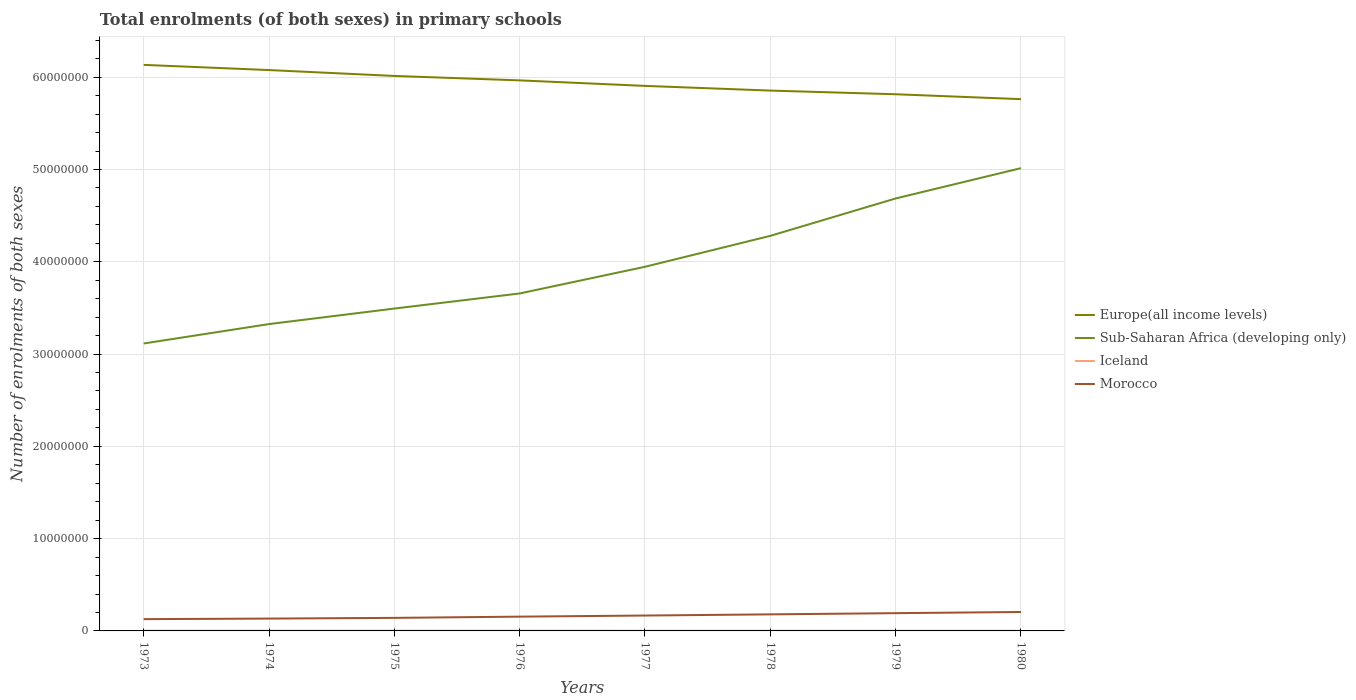How many different coloured lines are there?
Your response must be concise. 4. Across all years, what is the maximum number of enrolments in primary schools in Iceland?
Provide a short and direct response. 2.46e+04. What is the total number of enrolments in primary schools in Europe(all income levels) in the graph?
Provide a short and direct response. 1.44e+06. What is the difference between the highest and the second highest number of enrolments in primary schools in Europe(all income levels)?
Your answer should be compact. 3.71e+06. Is the number of enrolments in primary schools in Europe(all income levels) strictly greater than the number of enrolments in primary schools in Sub-Saharan Africa (developing only) over the years?
Ensure brevity in your answer.  No. How many lines are there?
Give a very brief answer. 4. Does the graph contain any zero values?
Offer a very short reply. No. Does the graph contain grids?
Keep it short and to the point. Yes. Where does the legend appear in the graph?
Provide a short and direct response. Center right. How many legend labels are there?
Your response must be concise. 4. How are the legend labels stacked?
Offer a very short reply. Vertical. What is the title of the graph?
Offer a very short reply. Total enrolments (of both sexes) in primary schools. What is the label or title of the X-axis?
Ensure brevity in your answer.  Years. What is the label or title of the Y-axis?
Give a very brief answer. Number of enrolments of both sexes. What is the Number of enrolments of both sexes in Europe(all income levels) in 1973?
Your answer should be compact. 6.13e+07. What is the Number of enrolments of both sexes of Sub-Saharan Africa (developing only) in 1973?
Your answer should be compact. 3.11e+07. What is the Number of enrolments of both sexes in Iceland in 1973?
Your answer should be compact. 2.72e+04. What is the Number of enrolments of both sexes in Morocco in 1973?
Offer a terse response. 1.28e+06. What is the Number of enrolments of both sexes of Europe(all income levels) in 1974?
Provide a short and direct response. 6.08e+07. What is the Number of enrolments of both sexes of Sub-Saharan Africa (developing only) in 1974?
Provide a succinct answer. 3.32e+07. What is the Number of enrolments of both sexes in Iceland in 1974?
Ensure brevity in your answer.  2.70e+04. What is the Number of enrolments of both sexes in Morocco in 1974?
Offer a terse response. 1.34e+06. What is the Number of enrolments of both sexes in Europe(all income levels) in 1975?
Offer a terse response. 6.01e+07. What is the Number of enrolments of both sexes in Sub-Saharan Africa (developing only) in 1975?
Provide a short and direct response. 3.49e+07. What is the Number of enrolments of both sexes in Iceland in 1975?
Provide a succinct answer. 2.69e+04. What is the Number of enrolments of both sexes of Morocco in 1975?
Provide a succinct answer. 1.41e+06. What is the Number of enrolments of both sexes in Europe(all income levels) in 1976?
Provide a short and direct response. 5.97e+07. What is the Number of enrolments of both sexes in Sub-Saharan Africa (developing only) in 1976?
Keep it short and to the point. 3.66e+07. What is the Number of enrolments of both sexes of Iceland in 1976?
Your response must be concise. 2.64e+04. What is the Number of enrolments of both sexes in Morocco in 1976?
Ensure brevity in your answer.  1.55e+06. What is the Number of enrolments of both sexes in Europe(all income levels) in 1977?
Your response must be concise. 5.91e+07. What is the Number of enrolments of both sexes in Sub-Saharan Africa (developing only) in 1977?
Make the answer very short. 3.95e+07. What is the Number of enrolments of both sexes of Iceland in 1977?
Provide a short and direct response. 2.59e+04. What is the Number of enrolments of both sexes in Morocco in 1977?
Your answer should be compact. 1.67e+06. What is the Number of enrolments of both sexes in Europe(all income levels) in 1978?
Provide a succinct answer. 5.86e+07. What is the Number of enrolments of both sexes of Sub-Saharan Africa (developing only) in 1978?
Give a very brief answer. 4.28e+07. What is the Number of enrolments of both sexes in Iceland in 1978?
Make the answer very short. 2.51e+04. What is the Number of enrolments of both sexes of Morocco in 1978?
Keep it short and to the point. 1.79e+06. What is the Number of enrolments of both sexes of Europe(all income levels) in 1979?
Give a very brief answer. 5.82e+07. What is the Number of enrolments of both sexes of Sub-Saharan Africa (developing only) in 1979?
Provide a short and direct response. 4.69e+07. What is the Number of enrolments of both sexes in Iceland in 1979?
Your response must be concise. 2.47e+04. What is the Number of enrolments of both sexes of Morocco in 1979?
Your answer should be very brief. 1.93e+06. What is the Number of enrolments of both sexes in Europe(all income levels) in 1980?
Ensure brevity in your answer.  5.76e+07. What is the Number of enrolments of both sexes in Sub-Saharan Africa (developing only) in 1980?
Offer a very short reply. 5.01e+07. What is the Number of enrolments of both sexes of Iceland in 1980?
Offer a very short reply. 2.46e+04. What is the Number of enrolments of both sexes in Morocco in 1980?
Provide a succinct answer. 2.05e+06. Across all years, what is the maximum Number of enrolments of both sexes of Europe(all income levels)?
Make the answer very short. 6.13e+07. Across all years, what is the maximum Number of enrolments of both sexes in Sub-Saharan Africa (developing only)?
Offer a terse response. 5.01e+07. Across all years, what is the maximum Number of enrolments of both sexes in Iceland?
Provide a succinct answer. 2.72e+04. Across all years, what is the maximum Number of enrolments of both sexes of Morocco?
Your response must be concise. 2.05e+06. Across all years, what is the minimum Number of enrolments of both sexes of Europe(all income levels)?
Offer a terse response. 5.76e+07. Across all years, what is the minimum Number of enrolments of both sexes of Sub-Saharan Africa (developing only)?
Your answer should be very brief. 3.11e+07. Across all years, what is the minimum Number of enrolments of both sexes of Iceland?
Your answer should be compact. 2.46e+04. Across all years, what is the minimum Number of enrolments of both sexes of Morocco?
Give a very brief answer. 1.28e+06. What is the total Number of enrolments of both sexes of Europe(all income levels) in the graph?
Make the answer very short. 4.75e+08. What is the total Number of enrolments of both sexes of Sub-Saharan Africa (developing only) in the graph?
Provide a short and direct response. 3.15e+08. What is the total Number of enrolments of both sexes of Iceland in the graph?
Ensure brevity in your answer.  2.08e+05. What is the total Number of enrolments of both sexes of Morocco in the graph?
Provide a short and direct response. 1.30e+07. What is the difference between the Number of enrolments of both sexes in Europe(all income levels) in 1973 and that in 1974?
Provide a succinct answer. 5.63e+05. What is the difference between the Number of enrolments of both sexes of Sub-Saharan Africa (developing only) in 1973 and that in 1974?
Your response must be concise. -2.10e+06. What is the difference between the Number of enrolments of both sexes in Iceland in 1973 and that in 1974?
Ensure brevity in your answer.  171. What is the difference between the Number of enrolments of both sexes of Morocco in 1973 and that in 1974?
Your answer should be very brief. -6.21e+04. What is the difference between the Number of enrolments of both sexes in Europe(all income levels) in 1973 and that in 1975?
Provide a succinct answer. 1.20e+06. What is the difference between the Number of enrolments of both sexes of Sub-Saharan Africa (developing only) in 1973 and that in 1975?
Provide a succinct answer. -3.79e+06. What is the difference between the Number of enrolments of both sexes of Iceland in 1973 and that in 1975?
Provide a succinct answer. 295. What is the difference between the Number of enrolments of both sexes in Morocco in 1973 and that in 1975?
Your answer should be very brief. -1.38e+05. What is the difference between the Number of enrolments of both sexes of Europe(all income levels) in 1973 and that in 1976?
Offer a terse response. 1.68e+06. What is the difference between the Number of enrolments of both sexes of Sub-Saharan Africa (developing only) in 1973 and that in 1976?
Your answer should be compact. -5.42e+06. What is the difference between the Number of enrolments of both sexes in Iceland in 1973 and that in 1976?
Your answer should be compact. 799. What is the difference between the Number of enrolments of both sexes of Morocco in 1973 and that in 1976?
Your response must be concise. -2.72e+05. What is the difference between the Number of enrolments of both sexes of Europe(all income levels) in 1973 and that in 1977?
Your response must be concise. 2.28e+06. What is the difference between the Number of enrolments of both sexes in Sub-Saharan Africa (developing only) in 1973 and that in 1977?
Your answer should be very brief. -8.31e+06. What is the difference between the Number of enrolments of both sexes of Iceland in 1973 and that in 1977?
Give a very brief answer. 1293. What is the difference between the Number of enrolments of both sexes of Morocco in 1973 and that in 1977?
Ensure brevity in your answer.  -3.92e+05. What is the difference between the Number of enrolments of both sexes in Europe(all income levels) in 1973 and that in 1978?
Ensure brevity in your answer.  2.79e+06. What is the difference between the Number of enrolments of both sexes in Sub-Saharan Africa (developing only) in 1973 and that in 1978?
Ensure brevity in your answer.  -1.17e+07. What is the difference between the Number of enrolments of both sexes in Iceland in 1973 and that in 1978?
Keep it short and to the point. 2079. What is the difference between the Number of enrolments of both sexes in Morocco in 1973 and that in 1978?
Provide a succinct answer. -5.18e+05. What is the difference between the Number of enrolments of both sexes in Europe(all income levels) in 1973 and that in 1979?
Offer a very short reply. 3.18e+06. What is the difference between the Number of enrolments of both sexes of Sub-Saharan Africa (developing only) in 1973 and that in 1979?
Your response must be concise. -1.57e+07. What is the difference between the Number of enrolments of both sexes in Iceland in 1973 and that in 1979?
Offer a terse response. 2530. What is the difference between the Number of enrolments of both sexes of Morocco in 1973 and that in 1979?
Offer a very short reply. -6.49e+05. What is the difference between the Number of enrolments of both sexes of Europe(all income levels) in 1973 and that in 1980?
Ensure brevity in your answer.  3.71e+06. What is the difference between the Number of enrolments of both sexes in Sub-Saharan Africa (developing only) in 1973 and that in 1980?
Ensure brevity in your answer.  -1.90e+07. What is the difference between the Number of enrolments of both sexes in Iceland in 1973 and that in 1980?
Give a very brief answer. 2618. What is the difference between the Number of enrolments of both sexes in Morocco in 1973 and that in 1980?
Ensure brevity in your answer.  -7.76e+05. What is the difference between the Number of enrolments of both sexes in Europe(all income levels) in 1974 and that in 1975?
Your answer should be compact. 6.37e+05. What is the difference between the Number of enrolments of both sexes of Sub-Saharan Africa (developing only) in 1974 and that in 1975?
Give a very brief answer. -1.68e+06. What is the difference between the Number of enrolments of both sexes of Iceland in 1974 and that in 1975?
Your response must be concise. 124. What is the difference between the Number of enrolments of both sexes of Morocco in 1974 and that in 1975?
Your response must be concise. -7.61e+04. What is the difference between the Number of enrolments of both sexes in Europe(all income levels) in 1974 and that in 1976?
Make the answer very short. 1.12e+06. What is the difference between the Number of enrolments of both sexes of Sub-Saharan Africa (developing only) in 1974 and that in 1976?
Your answer should be compact. -3.32e+06. What is the difference between the Number of enrolments of both sexes of Iceland in 1974 and that in 1976?
Your answer should be very brief. 628. What is the difference between the Number of enrolments of both sexes of Morocco in 1974 and that in 1976?
Make the answer very short. -2.10e+05. What is the difference between the Number of enrolments of both sexes in Europe(all income levels) in 1974 and that in 1977?
Make the answer very short. 1.72e+06. What is the difference between the Number of enrolments of both sexes in Sub-Saharan Africa (developing only) in 1974 and that in 1977?
Your answer should be very brief. -6.21e+06. What is the difference between the Number of enrolments of both sexes of Iceland in 1974 and that in 1977?
Provide a succinct answer. 1122. What is the difference between the Number of enrolments of both sexes in Morocco in 1974 and that in 1977?
Provide a succinct answer. -3.30e+05. What is the difference between the Number of enrolments of both sexes of Europe(all income levels) in 1974 and that in 1978?
Offer a terse response. 2.22e+06. What is the difference between the Number of enrolments of both sexes in Sub-Saharan Africa (developing only) in 1974 and that in 1978?
Provide a short and direct response. -9.56e+06. What is the difference between the Number of enrolments of both sexes of Iceland in 1974 and that in 1978?
Provide a succinct answer. 1908. What is the difference between the Number of enrolments of both sexes of Morocco in 1974 and that in 1978?
Offer a terse response. -4.56e+05. What is the difference between the Number of enrolments of both sexes in Europe(all income levels) in 1974 and that in 1979?
Make the answer very short. 2.62e+06. What is the difference between the Number of enrolments of both sexes of Sub-Saharan Africa (developing only) in 1974 and that in 1979?
Offer a terse response. -1.36e+07. What is the difference between the Number of enrolments of both sexes in Iceland in 1974 and that in 1979?
Your answer should be very brief. 2359. What is the difference between the Number of enrolments of both sexes of Morocco in 1974 and that in 1979?
Your answer should be compact. -5.87e+05. What is the difference between the Number of enrolments of both sexes in Europe(all income levels) in 1974 and that in 1980?
Your answer should be very brief. 3.15e+06. What is the difference between the Number of enrolments of both sexes in Sub-Saharan Africa (developing only) in 1974 and that in 1980?
Provide a succinct answer. -1.69e+07. What is the difference between the Number of enrolments of both sexes in Iceland in 1974 and that in 1980?
Provide a short and direct response. 2447. What is the difference between the Number of enrolments of both sexes of Morocco in 1974 and that in 1980?
Provide a short and direct response. -7.14e+05. What is the difference between the Number of enrolments of both sexes of Europe(all income levels) in 1975 and that in 1976?
Keep it short and to the point. 4.81e+05. What is the difference between the Number of enrolments of both sexes in Sub-Saharan Africa (developing only) in 1975 and that in 1976?
Keep it short and to the point. -1.63e+06. What is the difference between the Number of enrolments of both sexes of Iceland in 1975 and that in 1976?
Give a very brief answer. 504. What is the difference between the Number of enrolments of both sexes of Morocco in 1975 and that in 1976?
Keep it short and to the point. -1.34e+05. What is the difference between the Number of enrolments of both sexes in Europe(all income levels) in 1975 and that in 1977?
Offer a terse response. 1.08e+06. What is the difference between the Number of enrolments of both sexes of Sub-Saharan Africa (developing only) in 1975 and that in 1977?
Your answer should be compact. -4.53e+06. What is the difference between the Number of enrolments of both sexes of Iceland in 1975 and that in 1977?
Your answer should be very brief. 998. What is the difference between the Number of enrolments of both sexes in Morocco in 1975 and that in 1977?
Offer a terse response. -2.54e+05. What is the difference between the Number of enrolments of both sexes in Europe(all income levels) in 1975 and that in 1978?
Ensure brevity in your answer.  1.59e+06. What is the difference between the Number of enrolments of both sexes in Sub-Saharan Africa (developing only) in 1975 and that in 1978?
Keep it short and to the point. -7.88e+06. What is the difference between the Number of enrolments of both sexes of Iceland in 1975 and that in 1978?
Provide a succinct answer. 1784. What is the difference between the Number of enrolments of both sexes in Morocco in 1975 and that in 1978?
Your response must be concise. -3.80e+05. What is the difference between the Number of enrolments of both sexes in Europe(all income levels) in 1975 and that in 1979?
Your answer should be very brief. 1.98e+06. What is the difference between the Number of enrolments of both sexes of Sub-Saharan Africa (developing only) in 1975 and that in 1979?
Provide a succinct answer. -1.19e+07. What is the difference between the Number of enrolments of both sexes in Iceland in 1975 and that in 1979?
Provide a succinct answer. 2235. What is the difference between the Number of enrolments of both sexes of Morocco in 1975 and that in 1979?
Provide a short and direct response. -5.11e+05. What is the difference between the Number of enrolments of both sexes of Europe(all income levels) in 1975 and that in 1980?
Keep it short and to the point. 2.51e+06. What is the difference between the Number of enrolments of both sexes of Sub-Saharan Africa (developing only) in 1975 and that in 1980?
Your answer should be compact. -1.52e+07. What is the difference between the Number of enrolments of both sexes of Iceland in 1975 and that in 1980?
Offer a very short reply. 2323. What is the difference between the Number of enrolments of both sexes of Morocco in 1975 and that in 1980?
Provide a short and direct response. -6.38e+05. What is the difference between the Number of enrolments of both sexes of Europe(all income levels) in 1976 and that in 1977?
Your answer should be compact. 5.98e+05. What is the difference between the Number of enrolments of both sexes of Sub-Saharan Africa (developing only) in 1976 and that in 1977?
Provide a succinct answer. -2.89e+06. What is the difference between the Number of enrolments of both sexes of Iceland in 1976 and that in 1977?
Your response must be concise. 494. What is the difference between the Number of enrolments of both sexes in Morocco in 1976 and that in 1977?
Your response must be concise. -1.20e+05. What is the difference between the Number of enrolments of both sexes of Europe(all income levels) in 1976 and that in 1978?
Keep it short and to the point. 1.11e+06. What is the difference between the Number of enrolments of both sexes of Sub-Saharan Africa (developing only) in 1976 and that in 1978?
Provide a short and direct response. -6.24e+06. What is the difference between the Number of enrolments of both sexes in Iceland in 1976 and that in 1978?
Offer a very short reply. 1280. What is the difference between the Number of enrolments of both sexes in Morocco in 1976 and that in 1978?
Make the answer very short. -2.46e+05. What is the difference between the Number of enrolments of both sexes in Europe(all income levels) in 1976 and that in 1979?
Keep it short and to the point. 1.50e+06. What is the difference between the Number of enrolments of both sexes in Sub-Saharan Africa (developing only) in 1976 and that in 1979?
Offer a very short reply. -1.03e+07. What is the difference between the Number of enrolments of both sexes of Iceland in 1976 and that in 1979?
Offer a very short reply. 1731. What is the difference between the Number of enrolments of both sexes in Morocco in 1976 and that in 1979?
Your response must be concise. -3.78e+05. What is the difference between the Number of enrolments of both sexes in Europe(all income levels) in 1976 and that in 1980?
Your response must be concise. 2.03e+06. What is the difference between the Number of enrolments of both sexes in Sub-Saharan Africa (developing only) in 1976 and that in 1980?
Your answer should be very brief. -1.36e+07. What is the difference between the Number of enrolments of both sexes of Iceland in 1976 and that in 1980?
Offer a very short reply. 1819. What is the difference between the Number of enrolments of both sexes in Morocco in 1976 and that in 1980?
Offer a very short reply. -5.04e+05. What is the difference between the Number of enrolments of both sexes in Europe(all income levels) in 1977 and that in 1978?
Provide a short and direct response. 5.08e+05. What is the difference between the Number of enrolments of both sexes of Sub-Saharan Africa (developing only) in 1977 and that in 1978?
Your response must be concise. -3.35e+06. What is the difference between the Number of enrolments of both sexes of Iceland in 1977 and that in 1978?
Your answer should be very brief. 786. What is the difference between the Number of enrolments of both sexes in Morocco in 1977 and that in 1978?
Offer a terse response. -1.26e+05. What is the difference between the Number of enrolments of both sexes of Europe(all income levels) in 1977 and that in 1979?
Provide a succinct answer. 9.06e+05. What is the difference between the Number of enrolments of both sexes of Sub-Saharan Africa (developing only) in 1977 and that in 1979?
Offer a terse response. -7.40e+06. What is the difference between the Number of enrolments of both sexes of Iceland in 1977 and that in 1979?
Your response must be concise. 1237. What is the difference between the Number of enrolments of both sexes of Morocco in 1977 and that in 1979?
Ensure brevity in your answer.  -2.57e+05. What is the difference between the Number of enrolments of both sexes in Europe(all income levels) in 1977 and that in 1980?
Your response must be concise. 1.44e+06. What is the difference between the Number of enrolments of both sexes in Sub-Saharan Africa (developing only) in 1977 and that in 1980?
Offer a very short reply. -1.07e+07. What is the difference between the Number of enrolments of both sexes of Iceland in 1977 and that in 1980?
Keep it short and to the point. 1325. What is the difference between the Number of enrolments of both sexes of Morocco in 1977 and that in 1980?
Keep it short and to the point. -3.84e+05. What is the difference between the Number of enrolments of both sexes of Europe(all income levels) in 1978 and that in 1979?
Provide a succinct answer. 3.98e+05. What is the difference between the Number of enrolments of both sexes of Sub-Saharan Africa (developing only) in 1978 and that in 1979?
Provide a succinct answer. -4.05e+06. What is the difference between the Number of enrolments of both sexes of Iceland in 1978 and that in 1979?
Offer a terse response. 451. What is the difference between the Number of enrolments of both sexes of Morocco in 1978 and that in 1979?
Your answer should be compact. -1.31e+05. What is the difference between the Number of enrolments of both sexes of Europe(all income levels) in 1978 and that in 1980?
Keep it short and to the point. 9.27e+05. What is the difference between the Number of enrolments of both sexes of Sub-Saharan Africa (developing only) in 1978 and that in 1980?
Your answer should be compact. -7.34e+06. What is the difference between the Number of enrolments of both sexes of Iceland in 1978 and that in 1980?
Ensure brevity in your answer.  539. What is the difference between the Number of enrolments of both sexes of Morocco in 1978 and that in 1980?
Offer a terse response. -2.58e+05. What is the difference between the Number of enrolments of both sexes of Europe(all income levels) in 1979 and that in 1980?
Offer a very short reply. 5.30e+05. What is the difference between the Number of enrolments of both sexes in Sub-Saharan Africa (developing only) in 1979 and that in 1980?
Offer a very short reply. -3.28e+06. What is the difference between the Number of enrolments of both sexes of Iceland in 1979 and that in 1980?
Keep it short and to the point. 88. What is the difference between the Number of enrolments of both sexes of Morocco in 1979 and that in 1980?
Ensure brevity in your answer.  -1.27e+05. What is the difference between the Number of enrolments of both sexes of Europe(all income levels) in 1973 and the Number of enrolments of both sexes of Sub-Saharan Africa (developing only) in 1974?
Offer a terse response. 2.81e+07. What is the difference between the Number of enrolments of both sexes in Europe(all income levels) in 1973 and the Number of enrolments of both sexes in Iceland in 1974?
Provide a short and direct response. 6.13e+07. What is the difference between the Number of enrolments of both sexes of Europe(all income levels) in 1973 and the Number of enrolments of both sexes of Morocco in 1974?
Provide a short and direct response. 6.00e+07. What is the difference between the Number of enrolments of both sexes in Sub-Saharan Africa (developing only) in 1973 and the Number of enrolments of both sexes in Iceland in 1974?
Give a very brief answer. 3.11e+07. What is the difference between the Number of enrolments of both sexes in Sub-Saharan Africa (developing only) in 1973 and the Number of enrolments of both sexes in Morocco in 1974?
Give a very brief answer. 2.98e+07. What is the difference between the Number of enrolments of both sexes in Iceland in 1973 and the Number of enrolments of both sexes in Morocco in 1974?
Give a very brief answer. -1.31e+06. What is the difference between the Number of enrolments of both sexes in Europe(all income levels) in 1973 and the Number of enrolments of both sexes in Sub-Saharan Africa (developing only) in 1975?
Offer a very short reply. 2.64e+07. What is the difference between the Number of enrolments of both sexes of Europe(all income levels) in 1973 and the Number of enrolments of both sexes of Iceland in 1975?
Provide a succinct answer. 6.13e+07. What is the difference between the Number of enrolments of both sexes of Europe(all income levels) in 1973 and the Number of enrolments of both sexes of Morocco in 1975?
Your answer should be very brief. 5.99e+07. What is the difference between the Number of enrolments of both sexes in Sub-Saharan Africa (developing only) in 1973 and the Number of enrolments of both sexes in Iceland in 1975?
Give a very brief answer. 3.11e+07. What is the difference between the Number of enrolments of both sexes of Sub-Saharan Africa (developing only) in 1973 and the Number of enrolments of both sexes of Morocco in 1975?
Offer a terse response. 2.97e+07. What is the difference between the Number of enrolments of both sexes in Iceland in 1973 and the Number of enrolments of both sexes in Morocco in 1975?
Provide a succinct answer. -1.39e+06. What is the difference between the Number of enrolments of both sexes of Europe(all income levels) in 1973 and the Number of enrolments of both sexes of Sub-Saharan Africa (developing only) in 1976?
Your answer should be very brief. 2.48e+07. What is the difference between the Number of enrolments of both sexes of Europe(all income levels) in 1973 and the Number of enrolments of both sexes of Iceland in 1976?
Provide a short and direct response. 6.13e+07. What is the difference between the Number of enrolments of both sexes in Europe(all income levels) in 1973 and the Number of enrolments of both sexes in Morocco in 1976?
Offer a very short reply. 5.98e+07. What is the difference between the Number of enrolments of both sexes of Sub-Saharan Africa (developing only) in 1973 and the Number of enrolments of both sexes of Iceland in 1976?
Your answer should be compact. 3.11e+07. What is the difference between the Number of enrolments of both sexes of Sub-Saharan Africa (developing only) in 1973 and the Number of enrolments of both sexes of Morocco in 1976?
Your answer should be compact. 2.96e+07. What is the difference between the Number of enrolments of both sexes in Iceland in 1973 and the Number of enrolments of both sexes in Morocco in 1976?
Your response must be concise. -1.52e+06. What is the difference between the Number of enrolments of both sexes in Europe(all income levels) in 1973 and the Number of enrolments of both sexes in Sub-Saharan Africa (developing only) in 1977?
Your answer should be very brief. 2.19e+07. What is the difference between the Number of enrolments of both sexes in Europe(all income levels) in 1973 and the Number of enrolments of both sexes in Iceland in 1977?
Keep it short and to the point. 6.13e+07. What is the difference between the Number of enrolments of both sexes in Europe(all income levels) in 1973 and the Number of enrolments of both sexes in Morocco in 1977?
Your response must be concise. 5.97e+07. What is the difference between the Number of enrolments of both sexes in Sub-Saharan Africa (developing only) in 1973 and the Number of enrolments of both sexes in Iceland in 1977?
Your answer should be compact. 3.11e+07. What is the difference between the Number of enrolments of both sexes of Sub-Saharan Africa (developing only) in 1973 and the Number of enrolments of both sexes of Morocco in 1977?
Ensure brevity in your answer.  2.95e+07. What is the difference between the Number of enrolments of both sexes of Iceland in 1973 and the Number of enrolments of both sexes of Morocco in 1977?
Provide a succinct answer. -1.64e+06. What is the difference between the Number of enrolments of both sexes of Europe(all income levels) in 1973 and the Number of enrolments of both sexes of Sub-Saharan Africa (developing only) in 1978?
Make the answer very short. 1.85e+07. What is the difference between the Number of enrolments of both sexes in Europe(all income levels) in 1973 and the Number of enrolments of both sexes in Iceland in 1978?
Offer a very short reply. 6.13e+07. What is the difference between the Number of enrolments of both sexes of Europe(all income levels) in 1973 and the Number of enrolments of both sexes of Morocco in 1978?
Provide a succinct answer. 5.95e+07. What is the difference between the Number of enrolments of both sexes in Sub-Saharan Africa (developing only) in 1973 and the Number of enrolments of both sexes in Iceland in 1978?
Provide a short and direct response. 3.11e+07. What is the difference between the Number of enrolments of both sexes in Sub-Saharan Africa (developing only) in 1973 and the Number of enrolments of both sexes in Morocco in 1978?
Offer a terse response. 2.94e+07. What is the difference between the Number of enrolments of both sexes in Iceland in 1973 and the Number of enrolments of both sexes in Morocco in 1978?
Offer a very short reply. -1.77e+06. What is the difference between the Number of enrolments of both sexes in Europe(all income levels) in 1973 and the Number of enrolments of both sexes in Sub-Saharan Africa (developing only) in 1979?
Keep it short and to the point. 1.45e+07. What is the difference between the Number of enrolments of both sexes in Europe(all income levels) in 1973 and the Number of enrolments of both sexes in Iceland in 1979?
Offer a terse response. 6.13e+07. What is the difference between the Number of enrolments of both sexes of Europe(all income levels) in 1973 and the Number of enrolments of both sexes of Morocco in 1979?
Your answer should be very brief. 5.94e+07. What is the difference between the Number of enrolments of both sexes of Sub-Saharan Africa (developing only) in 1973 and the Number of enrolments of both sexes of Iceland in 1979?
Provide a short and direct response. 3.11e+07. What is the difference between the Number of enrolments of both sexes of Sub-Saharan Africa (developing only) in 1973 and the Number of enrolments of both sexes of Morocco in 1979?
Provide a short and direct response. 2.92e+07. What is the difference between the Number of enrolments of both sexes in Iceland in 1973 and the Number of enrolments of both sexes in Morocco in 1979?
Your answer should be compact. -1.90e+06. What is the difference between the Number of enrolments of both sexes of Europe(all income levels) in 1973 and the Number of enrolments of both sexes of Sub-Saharan Africa (developing only) in 1980?
Provide a succinct answer. 1.12e+07. What is the difference between the Number of enrolments of both sexes in Europe(all income levels) in 1973 and the Number of enrolments of both sexes in Iceland in 1980?
Your answer should be very brief. 6.13e+07. What is the difference between the Number of enrolments of both sexes in Europe(all income levels) in 1973 and the Number of enrolments of both sexes in Morocco in 1980?
Provide a succinct answer. 5.93e+07. What is the difference between the Number of enrolments of both sexes in Sub-Saharan Africa (developing only) in 1973 and the Number of enrolments of both sexes in Iceland in 1980?
Make the answer very short. 3.11e+07. What is the difference between the Number of enrolments of both sexes in Sub-Saharan Africa (developing only) in 1973 and the Number of enrolments of both sexes in Morocco in 1980?
Make the answer very short. 2.91e+07. What is the difference between the Number of enrolments of both sexes in Iceland in 1973 and the Number of enrolments of both sexes in Morocco in 1980?
Offer a terse response. -2.02e+06. What is the difference between the Number of enrolments of both sexes of Europe(all income levels) in 1974 and the Number of enrolments of both sexes of Sub-Saharan Africa (developing only) in 1975?
Your answer should be very brief. 2.58e+07. What is the difference between the Number of enrolments of both sexes in Europe(all income levels) in 1974 and the Number of enrolments of both sexes in Iceland in 1975?
Provide a succinct answer. 6.07e+07. What is the difference between the Number of enrolments of both sexes in Europe(all income levels) in 1974 and the Number of enrolments of both sexes in Morocco in 1975?
Offer a terse response. 5.94e+07. What is the difference between the Number of enrolments of both sexes of Sub-Saharan Africa (developing only) in 1974 and the Number of enrolments of both sexes of Iceland in 1975?
Your answer should be compact. 3.32e+07. What is the difference between the Number of enrolments of both sexes of Sub-Saharan Africa (developing only) in 1974 and the Number of enrolments of both sexes of Morocco in 1975?
Offer a terse response. 3.18e+07. What is the difference between the Number of enrolments of both sexes of Iceland in 1974 and the Number of enrolments of both sexes of Morocco in 1975?
Provide a short and direct response. -1.39e+06. What is the difference between the Number of enrolments of both sexes in Europe(all income levels) in 1974 and the Number of enrolments of both sexes in Sub-Saharan Africa (developing only) in 1976?
Give a very brief answer. 2.42e+07. What is the difference between the Number of enrolments of both sexes in Europe(all income levels) in 1974 and the Number of enrolments of both sexes in Iceland in 1976?
Your response must be concise. 6.07e+07. What is the difference between the Number of enrolments of both sexes in Europe(all income levels) in 1974 and the Number of enrolments of both sexes in Morocco in 1976?
Your answer should be compact. 5.92e+07. What is the difference between the Number of enrolments of both sexes of Sub-Saharan Africa (developing only) in 1974 and the Number of enrolments of both sexes of Iceland in 1976?
Your answer should be very brief. 3.32e+07. What is the difference between the Number of enrolments of both sexes of Sub-Saharan Africa (developing only) in 1974 and the Number of enrolments of both sexes of Morocco in 1976?
Keep it short and to the point. 3.17e+07. What is the difference between the Number of enrolments of both sexes in Iceland in 1974 and the Number of enrolments of both sexes in Morocco in 1976?
Make the answer very short. -1.52e+06. What is the difference between the Number of enrolments of both sexes of Europe(all income levels) in 1974 and the Number of enrolments of both sexes of Sub-Saharan Africa (developing only) in 1977?
Keep it short and to the point. 2.13e+07. What is the difference between the Number of enrolments of both sexes in Europe(all income levels) in 1974 and the Number of enrolments of both sexes in Iceland in 1977?
Keep it short and to the point. 6.07e+07. What is the difference between the Number of enrolments of both sexes in Europe(all income levels) in 1974 and the Number of enrolments of both sexes in Morocco in 1977?
Your answer should be very brief. 5.91e+07. What is the difference between the Number of enrolments of both sexes of Sub-Saharan Africa (developing only) in 1974 and the Number of enrolments of both sexes of Iceland in 1977?
Your answer should be compact. 3.32e+07. What is the difference between the Number of enrolments of both sexes of Sub-Saharan Africa (developing only) in 1974 and the Number of enrolments of both sexes of Morocco in 1977?
Provide a succinct answer. 3.16e+07. What is the difference between the Number of enrolments of both sexes in Iceland in 1974 and the Number of enrolments of both sexes in Morocco in 1977?
Provide a succinct answer. -1.64e+06. What is the difference between the Number of enrolments of both sexes in Europe(all income levels) in 1974 and the Number of enrolments of both sexes in Sub-Saharan Africa (developing only) in 1978?
Keep it short and to the point. 1.80e+07. What is the difference between the Number of enrolments of both sexes of Europe(all income levels) in 1974 and the Number of enrolments of both sexes of Iceland in 1978?
Provide a succinct answer. 6.07e+07. What is the difference between the Number of enrolments of both sexes of Europe(all income levels) in 1974 and the Number of enrolments of both sexes of Morocco in 1978?
Your answer should be compact. 5.90e+07. What is the difference between the Number of enrolments of both sexes of Sub-Saharan Africa (developing only) in 1974 and the Number of enrolments of both sexes of Iceland in 1978?
Ensure brevity in your answer.  3.32e+07. What is the difference between the Number of enrolments of both sexes in Sub-Saharan Africa (developing only) in 1974 and the Number of enrolments of both sexes in Morocco in 1978?
Provide a succinct answer. 3.15e+07. What is the difference between the Number of enrolments of both sexes in Iceland in 1974 and the Number of enrolments of both sexes in Morocco in 1978?
Keep it short and to the point. -1.77e+06. What is the difference between the Number of enrolments of both sexes in Europe(all income levels) in 1974 and the Number of enrolments of both sexes in Sub-Saharan Africa (developing only) in 1979?
Your answer should be compact. 1.39e+07. What is the difference between the Number of enrolments of both sexes in Europe(all income levels) in 1974 and the Number of enrolments of both sexes in Iceland in 1979?
Your response must be concise. 6.07e+07. What is the difference between the Number of enrolments of both sexes in Europe(all income levels) in 1974 and the Number of enrolments of both sexes in Morocco in 1979?
Offer a very short reply. 5.88e+07. What is the difference between the Number of enrolments of both sexes of Sub-Saharan Africa (developing only) in 1974 and the Number of enrolments of both sexes of Iceland in 1979?
Ensure brevity in your answer.  3.32e+07. What is the difference between the Number of enrolments of both sexes of Sub-Saharan Africa (developing only) in 1974 and the Number of enrolments of both sexes of Morocco in 1979?
Provide a short and direct response. 3.13e+07. What is the difference between the Number of enrolments of both sexes in Iceland in 1974 and the Number of enrolments of both sexes in Morocco in 1979?
Make the answer very short. -1.90e+06. What is the difference between the Number of enrolments of both sexes of Europe(all income levels) in 1974 and the Number of enrolments of both sexes of Sub-Saharan Africa (developing only) in 1980?
Ensure brevity in your answer.  1.06e+07. What is the difference between the Number of enrolments of both sexes of Europe(all income levels) in 1974 and the Number of enrolments of both sexes of Iceland in 1980?
Offer a very short reply. 6.07e+07. What is the difference between the Number of enrolments of both sexes of Europe(all income levels) in 1974 and the Number of enrolments of both sexes of Morocco in 1980?
Give a very brief answer. 5.87e+07. What is the difference between the Number of enrolments of both sexes in Sub-Saharan Africa (developing only) in 1974 and the Number of enrolments of both sexes in Iceland in 1980?
Offer a very short reply. 3.32e+07. What is the difference between the Number of enrolments of both sexes of Sub-Saharan Africa (developing only) in 1974 and the Number of enrolments of both sexes of Morocco in 1980?
Your answer should be very brief. 3.12e+07. What is the difference between the Number of enrolments of both sexes in Iceland in 1974 and the Number of enrolments of both sexes in Morocco in 1980?
Keep it short and to the point. -2.02e+06. What is the difference between the Number of enrolments of both sexes of Europe(all income levels) in 1975 and the Number of enrolments of both sexes of Sub-Saharan Africa (developing only) in 1976?
Your answer should be compact. 2.36e+07. What is the difference between the Number of enrolments of both sexes in Europe(all income levels) in 1975 and the Number of enrolments of both sexes in Iceland in 1976?
Your response must be concise. 6.01e+07. What is the difference between the Number of enrolments of both sexes in Europe(all income levels) in 1975 and the Number of enrolments of both sexes in Morocco in 1976?
Give a very brief answer. 5.86e+07. What is the difference between the Number of enrolments of both sexes in Sub-Saharan Africa (developing only) in 1975 and the Number of enrolments of both sexes in Iceland in 1976?
Your answer should be very brief. 3.49e+07. What is the difference between the Number of enrolments of both sexes of Sub-Saharan Africa (developing only) in 1975 and the Number of enrolments of both sexes of Morocco in 1976?
Make the answer very short. 3.34e+07. What is the difference between the Number of enrolments of both sexes in Iceland in 1975 and the Number of enrolments of both sexes in Morocco in 1976?
Keep it short and to the point. -1.52e+06. What is the difference between the Number of enrolments of both sexes of Europe(all income levels) in 1975 and the Number of enrolments of both sexes of Sub-Saharan Africa (developing only) in 1977?
Provide a short and direct response. 2.07e+07. What is the difference between the Number of enrolments of both sexes of Europe(all income levels) in 1975 and the Number of enrolments of both sexes of Iceland in 1977?
Provide a succinct answer. 6.01e+07. What is the difference between the Number of enrolments of both sexes of Europe(all income levels) in 1975 and the Number of enrolments of both sexes of Morocco in 1977?
Offer a very short reply. 5.85e+07. What is the difference between the Number of enrolments of both sexes in Sub-Saharan Africa (developing only) in 1975 and the Number of enrolments of both sexes in Iceland in 1977?
Make the answer very short. 3.49e+07. What is the difference between the Number of enrolments of both sexes in Sub-Saharan Africa (developing only) in 1975 and the Number of enrolments of both sexes in Morocco in 1977?
Your response must be concise. 3.33e+07. What is the difference between the Number of enrolments of both sexes of Iceland in 1975 and the Number of enrolments of both sexes of Morocco in 1977?
Provide a succinct answer. -1.64e+06. What is the difference between the Number of enrolments of both sexes in Europe(all income levels) in 1975 and the Number of enrolments of both sexes in Sub-Saharan Africa (developing only) in 1978?
Keep it short and to the point. 1.73e+07. What is the difference between the Number of enrolments of both sexes of Europe(all income levels) in 1975 and the Number of enrolments of both sexes of Iceland in 1978?
Make the answer very short. 6.01e+07. What is the difference between the Number of enrolments of both sexes in Europe(all income levels) in 1975 and the Number of enrolments of both sexes in Morocco in 1978?
Your response must be concise. 5.83e+07. What is the difference between the Number of enrolments of both sexes in Sub-Saharan Africa (developing only) in 1975 and the Number of enrolments of both sexes in Iceland in 1978?
Offer a terse response. 3.49e+07. What is the difference between the Number of enrolments of both sexes of Sub-Saharan Africa (developing only) in 1975 and the Number of enrolments of both sexes of Morocco in 1978?
Keep it short and to the point. 3.31e+07. What is the difference between the Number of enrolments of both sexes in Iceland in 1975 and the Number of enrolments of both sexes in Morocco in 1978?
Provide a short and direct response. -1.77e+06. What is the difference between the Number of enrolments of both sexes in Europe(all income levels) in 1975 and the Number of enrolments of both sexes in Sub-Saharan Africa (developing only) in 1979?
Provide a succinct answer. 1.33e+07. What is the difference between the Number of enrolments of both sexes in Europe(all income levels) in 1975 and the Number of enrolments of both sexes in Iceland in 1979?
Offer a terse response. 6.01e+07. What is the difference between the Number of enrolments of both sexes in Europe(all income levels) in 1975 and the Number of enrolments of both sexes in Morocco in 1979?
Provide a succinct answer. 5.82e+07. What is the difference between the Number of enrolments of both sexes of Sub-Saharan Africa (developing only) in 1975 and the Number of enrolments of both sexes of Iceland in 1979?
Your answer should be very brief. 3.49e+07. What is the difference between the Number of enrolments of both sexes in Sub-Saharan Africa (developing only) in 1975 and the Number of enrolments of both sexes in Morocco in 1979?
Give a very brief answer. 3.30e+07. What is the difference between the Number of enrolments of both sexes of Iceland in 1975 and the Number of enrolments of both sexes of Morocco in 1979?
Provide a short and direct response. -1.90e+06. What is the difference between the Number of enrolments of both sexes of Europe(all income levels) in 1975 and the Number of enrolments of both sexes of Sub-Saharan Africa (developing only) in 1980?
Make the answer very short. 9.99e+06. What is the difference between the Number of enrolments of both sexes of Europe(all income levels) in 1975 and the Number of enrolments of both sexes of Iceland in 1980?
Provide a short and direct response. 6.01e+07. What is the difference between the Number of enrolments of both sexes in Europe(all income levels) in 1975 and the Number of enrolments of both sexes in Morocco in 1980?
Ensure brevity in your answer.  5.81e+07. What is the difference between the Number of enrolments of both sexes of Sub-Saharan Africa (developing only) in 1975 and the Number of enrolments of both sexes of Iceland in 1980?
Provide a succinct answer. 3.49e+07. What is the difference between the Number of enrolments of both sexes in Sub-Saharan Africa (developing only) in 1975 and the Number of enrolments of both sexes in Morocco in 1980?
Your response must be concise. 3.29e+07. What is the difference between the Number of enrolments of both sexes of Iceland in 1975 and the Number of enrolments of both sexes of Morocco in 1980?
Give a very brief answer. -2.02e+06. What is the difference between the Number of enrolments of both sexes in Europe(all income levels) in 1976 and the Number of enrolments of both sexes in Sub-Saharan Africa (developing only) in 1977?
Your answer should be very brief. 2.02e+07. What is the difference between the Number of enrolments of both sexes in Europe(all income levels) in 1976 and the Number of enrolments of both sexes in Iceland in 1977?
Offer a terse response. 5.96e+07. What is the difference between the Number of enrolments of both sexes of Europe(all income levels) in 1976 and the Number of enrolments of both sexes of Morocco in 1977?
Make the answer very short. 5.80e+07. What is the difference between the Number of enrolments of both sexes in Sub-Saharan Africa (developing only) in 1976 and the Number of enrolments of both sexes in Iceland in 1977?
Offer a very short reply. 3.65e+07. What is the difference between the Number of enrolments of both sexes of Sub-Saharan Africa (developing only) in 1976 and the Number of enrolments of both sexes of Morocco in 1977?
Keep it short and to the point. 3.49e+07. What is the difference between the Number of enrolments of both sexes of Iceland in 1976 and the Number of enrolments of both sexes of Morocco in 1977?
Offer a terse response. -1.64e+06. What is the difference between the Number of enrolments of both sexes in Europe(all income levels) in 1976 and the Number of enrolments of both sexes in Sub-Saharan Africa (developing only) in 1978?
Offer a terse response. 1.68e+07. What is the difference between the Number of enrolments of both sexes in Europe(all income levels) in 1976 and the Number of enrolments of both sexes in Iceland in 1978?
Offer a very short reply. 5.96e+07. What is the difference between the Number of enrolments of both sexes of Europe(all income levels) in 1976 and the Number of enrolments of both sexes of Morocco in 1978?
Offer a terse response. 5.79e+07. What is the difference between the Number of enrolments of both sexes in Sub-Saharan Africa (developing only) in 1976 and the Number of enrolments of both sexes in Iceland in 1978?
Offer a very short reply. 3.65e+07. What is the difference between the Number of enrolments of both sexes in Sub-Saharan Africa (developing only) in 1976 and the Number of enrolments of both sexes in Morocco in 1978?
Your response must be concise. 3.48e+07. What is the difference between the Number of enrolments of both sexes in Iceland in 1976 and the Number of enrolments of both sexes in Morocco in 1978?
Provide a succinct answer. -1.77e+06. What is the difference between the Number of enrolments of both sexes in Europe(all income levels) in 1976 and the Number of enrolments of both sexes in Sub-Saharan Africa (developing only) in 1979?
Keep it short and to the point. 1.28e+07. What is the difference between the Number of enrolments of both sexes in Europe(all income levels) in 1976 and the Number of enrolments of both sexes in Iceland in 1979?
Give a very brief answer. 5.96e+07. What is the difference between the Number of enrolments of both sexes of Europe(all income levels) in 1976 and the Number of enrolments of both sexes of Morocco in 1979?
Ensure brevity in your answer.  5.77e+07. What is the difference between the Number of enrolments of both sexes of Sub-Saharan Africa (developing only) in 1976 and the Number of enrolments of both sexes of Iceland in 1979?
Ensure brevity in your answer.  3.65e+07. What is the difference between the Number of enrolments of both sexes of Sub-Saharan Africa (developing only) in 1976 and the Number of enrolments of both sexes of Morocco in 1979?
Make the answer very short. 3.46e+07. What is the difference between the Number of enrolments of both sexes of Iceland in 1976 and the Number of enrolments of both sexes of Morocco in 1979?
Keep it short and to the point. -1.90e+06. What is the difference between the Number of enrolments of both sexes in Europe(all income levels) in 1976 and the Number of enrolments of both sexes in Sub-Saharan Africa (developing only) in 1980?
Offer a terse response. 9.51e+06. What is the difference between the Number of enrolments of both sexes in Europe(all income levels) in 1976 and the Number of enrolments of both sexes in Iceland in 1980?
Offer a very short reply. 5.96e+07. What is the difference between the Number of enrolments of both sexes of Europe(all income levels) in 1976 and the Number of enrolments of both sexes of Morocco in 1980?
Your answer should be compact. 5.76e+07. What is the difference between the Number of enrolments of both sexes of Sub-Saharan Africa (developing only) in 1976 and the Number of enrolments of both sexes of Iceland in 1980?
Ensure brevity in your answer.  3.65e+07. What is the difference between the Number of enrolments of both sexes in Sub-Saharan Africa (developing only) in 1976 and the Number of enrolments of both sexes in Morocco in 1980?
Ensure brevity in your answer.  3.45e+07. What is the difference between the Number of enrolments of both sexes of Iceland in 1976 and the Number of enrolments of both sexes of Morocco in 1980?
Make the answer very short. -2.03e+06. What is the difference between the Number of enrolments of both sexes of Europe(all income levels) in 1977 and the Number of enrolments of both sexes of Sub-Saharan Africa (developing only) in 1978?
Give a very brief answer. 1.62e+07. What is the difference between the Number of enrolments of both sexes in Europe(all income levels) in 1977 and the Number of enrolments of both sexes in Iceland in 1978?
Ensure brevity in your answer.  5.90e+07. What is the difference between the Number of enrolments of both sexes in Europe(all income levels) in 1977 and the Number of enrolments of both sexes in Morocco in 1978?
Ensure brevity in your answer.  5.73e+07. What is the difference between the Number of enrolments of both sexes of Sub-Saharan Africa (developing only) in 1977 and the Number of enrolments of both sexes of Iceland in 1978?
Provide a short and direct response. 3.94e+07. What is the difference between the Number of enrolments of both sexes in Sub-Saharan Africa (developing only) in 1977 and the Number of enrolments of both sexes in Morocco in 1978?
Make the answer very short. 3.77e+07. What is the difference between the Number of enrolments of both sexes in Iceland in 1977 and the Number of enrolments of both sexes in Morocco in 1978?
Offer a very short reply. -1.77e+06. What is the difference between the Number of enrolments of both sexes of Europe(all income levels) in 1977 and the Number of enrolments of both sexes of Sub-Saharan Africa (developing only) in 1979?
Your answer should be very brief. 1.22e+07. What is the difference between the Number of enrolments of both sexes of Europe(all income levels) in 1977 and the Number of enrolments of both sexes of Iceland in 1979?
Provide a succinct answer. 5.90e+07. What is the difference between the Number of enrolments of both sexes of Europe(all income levels) in 1977 and the Number of enrolments of both sexes of Morocco in 1979?
Provide a succinct answer. 5.71e+07. What is the difference between the Number of enrolments of both sexes of Sub-Saharan Africa (developing only) in 1977 and the Number of enrolments of both sexes of Iceland in 1979?
Your response must be concise. 3.94e+07. What is the difference between the Number of enrolments of both sexes of Sub-Saharan Africa (developing only) in 1977 and the Number of enrolments of both sexes of Morocco in 1979?
Offer a terse response. 3.75e+07. What is the difference between the Number of enrolments of both sexes of Iceland in 1977 and the Number of enrolments of both sexes of Morocco in 1979?
Provide a short and direct response. -1.90e+06. What is the difference between the Number of enrolments of both sexes of Europe(all income levels) in 1977 and the Number of enrolments of both sexes of Sub-Saharan Africa (developing only) in 1980?
Provide a short and direct response. 8.91e+06. What is the difference between the Number of enrolments of both sexes in Europe(all income levels) in 1977 and the Number of enrolments of both sexes in Iceland in 1980?
Ensure brevity in your answer.  5.90e+07. What is the difference between the Number of enrolments of both sexes in Europe(all income levels) in 1977 and the Number of enrolments of both sexes in Morocco in 1980?
Your response must be concise. 5.70e+07. What is the difference between the Number of enrolments of both sexes in Sub-Saharan Africa (developing only) in 1977 and the Number of enrolments of both sexes in Iceland in 1980?
Keep it short and to the point. 3.94e+07. What is the difference between the Number of enrolments of both sexes in Sub-Saharan Africa (developing only) in 1977 and the Number of enrolments of both sexes in Morocco in 1980?
Your answer should be very brief. 3.74e+07. What is the difference between the Number of enrolments of both sexes of Iceland in 1977 and the Number of enrolments of both sexes of Morocco in 1980?
Ensure brevity in your answer.  -2.03e+06. What is the difference between the Number of enrolments of both sexes of Europe(all income levels) in 1978 and the Number of enrolments of both sexes of Sub-Saharan Africa (developing only) in 1979?
Your answer should be compact. 1.17e+07. What is the difference between the Number of enrolments of both sexes in Europe(all income levels) in 1978 and the Number of enrolments of both sexes in Iceland in 1979?
Ensure brevity in your answer.  5.85e+07. What is the difference between the Number of enrolments of both sexes of Europe(all income levels) in 1978 and the Number of enrolments of both sexes of Morocco in 1979?
Your response must be concise. 5.66e+07. What is the difference between the Number of enrolments of both sexes of Sub-Saharan Africa (developing only) in 1978 and the Number of enrolments of both sexes of Iceland in 1979?
Your response must be concise. 4.28e+07. What is the difference between the Number of enrolments of both sexes in Sub-Saharan Africa (developing only) in 1978 and the Number of enrolments of both sexes in Morocco in 1979?
Ensure brevity in your answer.  4.09e+07. What is the difference between the Number of enrolments of both sexes in Iceland in 1978 and the Number of enrolments of both sexes in Morocco in 1979?
Offer a very short reply. -1.90e+06. What is the difference between the Number of enrolments of both sexes in Europe(all income levels) in 1978 and the Number of enrolments of both sexes in Sub-Saharan Africa (developing only) in 1980?
Offer a very short reply. 8.41e+06. What is the difference between the Number of enrolments of both sexes in Europe(all income levels) in 1978 and the Number of enrolments of both sexes in Iceland in 1980?
Give a very brief answer. 5.85e+07. What is the difference between the Number of enrolments of both sexes of Europe(all income levels) in 1978 and the Number of enrolments of both sexes of Morocco in 1980?
Provide a succinct answer. 5.65e+07. What is the difference between the Number of enrolments of both sexes of Sub-Saharan Africa (developing only) in 1978 and the Number of enrolments of both sexes of Iceland in 1980?
Your answer should be very brief. 4.28e+07. What is the difference between the Number of enrolments of both sexes of Sub-Saharan Africa (developing only) in 1978 and the Number of enrolments of both sexes of Morocco in 1980?
Provide a short and direct response. 4.08e+07. What is the difference between the Number of enrolments of both sexes in Iceland in 1978 and the Number of enrolments of both sexes in Morocco in 1980?
Ensure brevity in your answer.  -2.03e+06. What is the difference between the Number of enrolments of both sexes of Europe(all income levels) in 1979 and the Number of enrolments of both sexes of Sub-Saharan Africa (developing only) in 1980?
Keep it short and to the point. 8.01e+06. What is the difference between the Number of enrolments of both sexes of Europe(all income levels) in 1979 and the Number of enrolments of both sexes of Iceland in 1980?
Offer a very short reply. 5.81e+07. What is the difference between the Number of enrolments of both sexes of Europe(all income levels) in 1979 and the Number of enrolments of both sexes of Morocco in 1980?
Your answer should be very brief. 5.61e+07. What is the difference between the Number of enrolments of both sexes in Sub-Saharan Africa (developing only) in 1979 and the Number of enrolments of both sexes in Iceland in 1980?
Provide a short and direct response. 4.68e+07. What is the difference between the Number of enrolments of both sexes in Sub-Saharan Africa (developing only) in 1979 and the Number of enrolments of both sexes in Morocco in 1980?
Give a very brief answer. 4.48e+07. What is the difference between the Number of enrolments of both sexes in Iceland in 1979 and the Number of enrolments of both sexes in Morocco in 1980?
Give a very brief answer. -2.03e+06. What is the average Number of enrolments of both sexes of Europe(all income levels) per year?
Give a very brief answer. 5.94e+07. What is the average Number of enrolments of both sexes of Sub-Saharan Africa (developing only) per year?
Provide a succinct answer. 3.94e+07. What is the average Number of enrolments of both sexes of Iceland per year?
Your response must be concise. 2.60e+04. What is the average Number of enrolments of both sexes in Morocco per year?
Your response must be concise. 1.63e+06. In the year 1973, what is the difference between the Number of enrolments of both sexes of Europe(all income levels) and Number of enrolments of both sexes of Sub-Saharan Africa (developing only)?
Your answer should be compact. 3.02e+07. In the year 1973, what is the difference between the Number of enrolments of both sexes of Europe(all income levels) and Number of enrolments of both sexes of Iceland?
Offer a terse response. 6.13e+07. In the year 1973, what is the difference between the Number of enrolments of both sexes of Europe(all income levels) and Number of enrolments of both sexes of Morocco?
Keep it short and to the point. 6.01e+07. In the year 1973, what is the difference between the Number of enrolments of both sexes of Sub-Saharan Africa (developing only) and Number of enrolments of both sexes of Iceland?
Ensure brevity in your answer.  3.11e+07. In the year 1973, what is the difference between the Number of enrolments of both sexes of Sub-Saharan Africa (developing only) and Number of enrolments of both sexes of Morocco?
Your answer should be very brief. 2.99e+07. In the year 1973, what is the difference between the Number of enrolments of both sexes of Iceland and Number of enrolments of both sexes of Morocco?
Give a very brief answer. -1.25e+06. In the year 1974, what is the difference between the Number of enrolments of both sexes in Europe(all income levels) and Number of enrolments of both sexes in Sub-Saharan Africa (developing only)?
Provide a succinct answer. 2.75e+07. In the year 1974, what is the difference between the Number of enrolments of both sexes in Europe(all income levels) and Number of enrolments of both sexes in Iceland?
Offer a terse response. 6.07e+07. In the year 1974, what is the difference between the Number of enrolments of both sexes in Europe(all income levels) and Number of enrolments of both sexes in Morocco?
Give a very brief answer. 5.94e+07. In the year 1974, what is the difference between the Number of enrolments of both sexes in Sub-Saharan Africa (developing only) and Number of enrolments of both sexes in Iceland?
Provide a short and direct response. 3.32e+07. In the year 1974, what is the difference between the Number of enrolments of both sexes of Sub-Saharan Africa (developing only) and Number of enrolments of both sexes of Morocco?
Your response must be concise. 3.19e+07. In the year 1974, what is the difference between the Number of enrolments of both sexes in Iceland and Number of enrolments of both sexes in Morocco?
Your response must be concise. -1.31e+06. In the year 1975, what is the difference between the Number of enrolments of both sexes in Europe(all income levels) and Number of enrolments of both sexes in Sub-Saharan Africa (developing only)?
Give a very brief answer. 2.52e+07. In the year 1975, what is the difference between the Number of enrolments of both sexes of Europe(all income levels) and Number of enrolments of both sexes of Iceland?
Make the answer very short. 6.01e+07. In the year 1975, what is the difference between the Number of enrolments of both sexes of Europe(all income levels) and Number of enrolments of both sexes of Morocco?
Provide a succinct answer. 5.87e+07. In the year 1975, what is the difference between the Number of enrolments of both sexes in Sub-Saharan Africa (developing only) and Number of enrolments of both sexes in Iceland?
Your answer should be compact. 3.49e+07. In the year 1975, what is the difference between the Number of enrolments of both sexes of Sub-Saharan Africa (developing only) and Number of enrolments of both sexes of Morocco?
Make the answer very short. 3.35e+07. In the year 1975, what is the difference between the Number of enrolments of both sexes in Iceland and Number of enrolments of both sexes in Morocco?
Give a very brief answer. -1.39e+06. In the year 1976, what is the difference between the Number of enrolments of both sexes of Europe(all income levels) and Number of enrolments of both sexes of Sub-Saharan Africa (developing only)?
Provide a succinct answer. 2.31e+07. In the year 1976, what is the difference between the Number of enrolments of both sexes in Europe(all income levels) and Number of enrolments of both sexes in Iceland?
Ensure brevity in your answer.  5.96e+07. In the year 1976, what is the difference between the Number of enrolments of both sexes of Europe(all income levels) and Number of enrolments of both sexes of Morocco?
Offer a terse response. 5.81e+07. In the year 1976, what is the difference between the Number of enrolments of both sexes of Sub-Saharan Africa (developing only) and Number of enrolments of both sexes of Iceland?
Provide a short and direct response. 3.65e+07. In the year 1976, what is the difference between the Number of enrolments of both sexes in Sub-Saharan Africa (developing only) and Number of enrolments of both sexes in Morocco?
Provide a short and direct response. 3.50e+07. In the year 1976, what is the difference between the Number of enrolments of both sexes of Iceland and Number of enrolments of both sexes of Morocco?
Provide a short and direct response. -1.52e+06. In the year 1977, what is the difference between the Number of enrolments of both sexes of Europe(all income levels) and Number of enrolments of both sexes of Sub-Saharan Africa (developing only)?
Ensure brevity in your answer.  1.96e+07. In the year 1977, what is the difference between the Number of enrolments of both sexes in Europe(all income levels) and Number of enrolments of both sexes in Iceland?
Provide a succinct answer. 5.90e+07. In the year 1977, what is the difference between the Number of enrolments of both sexes of Europe(all income levels) and Number of enrolments of both sexes of Morocco?
Ensure brevity in your answer.  5.74e+07. In the year 1977, what is the difference between the Number of enrolments of both sexes in Sub-Saharan Africa (developing only) and Number of enrolments of both sexes in Iceland?
Your answer should be compact. 3.94e+07. In the year 1977, what is the difference between the Number of enrolments of both sexes of Sub-Saharan Africa (developing only) and Number of enrolments of both sexes of Morocco?
Give a very brief answer. 3.78e+07. In the year 1977, what is the difference between the Number of enrolments of both sexes in Iceland and Number of enrolments of both sexes in Morocco?
Offer a terse response. -1.64e+06. In the year 1978, what is the difference between the Number of enrolments of both sexes of Europe(all income levels) and Number of enrolments of both sexes of Sub-Saharan Africa (developing only)?
Give a very brief answer. 1.57e+07. In the year 1978, what is the difference between the Number of enrolments of both sexes of Europe(all income levels) and Number of enrolments of both sexes of Iceland?
Provide a succinct answer. 5.85e+07. In the year 1978, what is the difference between the Number of enrolments of both sexes of Europe(all income levels) and Number of enrolments of both sexes of Morocco?
Keep it short and to the point. 5.68e+07. In the year 1978, what is the difference between the Number of enrolments of both sexes in Sub-Saharan Africa (developing only) and Number of enrolments of both sexes in Iceland?
Make the answer very short. 4.28e+07. In the year 1978, what is the difference between the Number of enrolments of both sexes of Sub-Saharan Africa (developing only) and Number of enrolments of both sexes of Morocco?
Your answer should be very brief. 4.10e+07. In the year 1978, what is the difference between the Number of enrolments of both sexes in Iceland and Number of enrolments of both sexes in Morocco?
Give a very brief answer. -1.77e+06. In the year 1979, what is the difference between the Number of enrolments of both sexes of Europe(all income levels) and Number of enrolments of both sexes of Sub-Saharan Africa (developing only)?
Make the answer very short. 1.13e+07. In the year 1979, what is the difference between the Number of enrolments of both sexes of Europe(all income levels) and Number of enrolments of both sexes of Iceland?
Your answer should be compact. 5.81e+07. In the year 1979, what is the difference between the Number of enrolments of both sexes in Europe(all income levels) and Number of enrolments of both sexes in Morocco?
Offer a very short reply. 5.62e+07. In the year 1979, what is the difference between the Number of enrolments of both sexes of Sub-Saharan Africa (developing only) and Number of enrolments of both sexes of Iceland?
Offer a terse response. 4.68e+07. In the year 1979, what is the difference between the Number of enrolments of both sexes in Sub-Saharan Africa (developing only) and Number of enrolments of both sexes in Morocco?
Your answer should be very brief. 4.49e+07. In the year 1979, what is the difference between the Number of enrolments of both sexes of Iceland and Number of enrolments of both sexes of Morocco?
Provide a short and direct response. -1.90e+06. In the year 1980, what is the difference between the Number of enrolments of both sexes in Europe(all income levels) and Number of enrolments of both sexes in Sub-Saharan Africa (developing only)?
Provide a short and direct response. 7.48e+06. In the year 1980, what is the difference between the Number of enrolments of both sexes of Europe(all income levels) and Number of enrolments of both sexes of Iceland?
Give a very brief answer. 5.76e+07. In the year 1980, what is the difference between the Number of enrolments of both sexes in Europe(all income levels) and Number of enrolments of both sexes in Morocco?
Ensure brevity in your answer.  5.56e+07. In the year 1980, what is the difference between the Number of enrolments of both sexes of Sub-Saharan Africa (developing only) and Number of enrolments of both sexes of Iceland?
Provide a succinct answer. 5.01e+07. In the year 1980, what is the difference between the Number of enrolments of both sexes of Sub-Saharan Africa (developing only) and Number of enrolments of both sexes of Morocco?
Give a very brief answer. 4.81e+07. In the year 1980, what is the difference between the Number of enrolments of both sexes in Iceland and Number of enrolments of both sexes in Morocco?
Give a very brief answer. -2.03e+06. What is the ratio of the Number of enrolments of both sexes in Europe(all income levels) in 1973 to that in 1974?
Offer a terse response. 1.01. What is the ratio of the Number of enrolments of both sexes of Sub-Saharan Africa (developing only) in 1973 to that in 1974?
Provide a short and direct response. 0.94. What is the ratio of the Number of enrolments of both sexes in Iceland in 1973 to that in 1974?
Provide a succinct answer. 1.01. What is the ratio of the Number of enrolments of both sexes in Morocco in 1973 to that in 1974?
Provide a succinct answer. 0.95. What is the ratio of the Number of enrolments of both sexes in Europe(all income levels) in 1973 to that in 1975?
Your answer should be compact. 1.02. What is the ratio of the Number of enrolments of both sexes in Sub-Saharan Africa (developing only) in 1973 to that in 1975?
Offer a very short reply. 0.89. What is the ratio of the Number of enrolments of both sexes of Morocco in 1973 to that in 1975?
Ensure brevity in your answer.  0.9. What is the ratio of the Number of enrolments of both sexes of Europe(all income levels) in 1973 to that in 1976?
Your answer should be very brief. 1.03. What is the ratio of the Number of enrolments of both sexes of Sub-Saharan Africa (developing only) in 1973 to that in 1976?
Ensure brevity in your answer.  0.85. What is the ratio of the Number of enrolments of both sexes in Iceland in 1973 to that in 1976?
Your answer should be compact. 1.03. What is the ratio of the Number of enrolments of both sexes in Morocco in 1973 to that in 1976?
Your response must be concise. 0.82. What is the ratio of the Number of enrolments of both sexes in Europe(all income levels) in 1973 to that in 1977?
Your answer should be compact. 1.04. What is the ratio of the Number of enrolments of both sexes of Sub-Saharan Africa (developing only) in 1973 to that in 1977?
Give a very brief answer. 0.79. What is the ratio of the Number of enrolments of both sexes of Iceland in 1973 to that in 1977?
Provide a short and direct response. 1.05. What is the ratio of the Number of enrolments of both sexes of Morocco in 1973 to that in 1977?
Your answer should be very brief. 0.77. What is the ratio of the Number of enrolments of both sexes of Europe(all income levels) in 1973 to that in 1978?
Keep it short and to the point. 1.05. What is the ratio of the Number of enrolments of both sexes in Sub-Saharan Africa (developing only) in 1973 to that in 1978?
Provide a succinct answer. 0.73. What is the ratio of the Number of enrolments of both sexes of Iceland in 1973 to that in 1978?
Your answer should be very brief. 1.08. What is the ratio of the Number of enrolments of both sexes in Morocco in 1973 to that in 1978?
Your response must be concise. 0.71. What is the ratio of the Number of enrolments of both sexes of Europe(all income levels) in 1973 to that in 1979?
Provide a succinct answer. 1.05. What is the ratio of the Number of enrolments of both sexes of Sub-Saharan Africa (developing only) in 1973 to that in 1979?
Make the answer very short. 0.66. What is the ratio of the Number of enrolments of both sexes of Iceland in 1973 to that in 1979?
Give a very brief answer. 1.1. What is the ratio of the Number of enrolments of both sexes in Morocco in 1973 to that in 1979?
Offer a terse response. 0.66. What is the ratio of the Number of enrolments of both sexes of Europe(all income levels) in 1973 to that in 1980?
Provide a succinct answer. 1.06. What is the ratio of the Number of enrolments of both sexes of Sub-Saharan Africa (developing only) in 1973 to that in 1980?
Offer a very short reply. 0.62. What is the ratio of the Number of enrolments of both sexes of Iceland in 1973 to that in 1980?
Make the answer very short. 1.11. What is the ratio of the Number of enrolments of both sexes in Morocco in 1973 to that in 1980?
Offer a very short reply. 0.62. What is the ratio of the Number of enrolments of both sexes of Europe(all income levels) in 1974 to that in 1975?
Provide a short and direct response. 1.01. What is the ratio of the Number of enrolments of both sexes of Sub-Saharan Africa (developing only) in 1974 to that in 1975?
Make the answer very short. 0.95. What is the ratio of the Number of enrolments of both sexes of Iceland in 1974 to that in 1975?
Your response must be concise. 1. What is the ratio of the Number of enrolments of both sexes of Morocco in 1974 to that in 1975?
Provide a succinct answer. 0.95. What is the ratio of the Number of enrolments of both sexes of Europe(all income levels) in 1974 to that in 1976?
Your answer should be compact. 1.02. What is the ratio of the Number of enrolments of both sexes in Sub-Saharan Africa (developing only) in 1974 to that in 1976?
Ensure brevity in your answer.  0.91. What is the ratio of the Number of enrolments of both sexes in Iceland in 1974 to that in 1976?
Provide a succinct answer. 1.02. What is the ratio of the Number of enrolments of both sexes of Morocco in 1974 to that in 1976?
Provide a short and direct response. 0.86. What is the ratio of the Number of enrolments of both sexes of Sub-Saharan Africa (developing only) in 1974 to that in 1977?
Offer a terse response. 0.84. What is the ratio of the Number of enrolments of both sexes in Iceland in 1974 to that in 1977?
Keep it short and to the point. 1.04. What is the ratio of the Number of enrolments of both sexes of Morocco in 1974 to that in 1977?
Make the answer very short. 0.8. What is the ratio of the Number of enrolments of both sexes of Europe(all income levels) in 1974 to that in 1978?
Keep it short and to the point. 1.04. What is the ratio of the Number of enrolments of both sexes in Sub-Saharan Africa (developing only) in 1974 to that in 1978?
Your answer should be very brief. 0.78. What is the ratio of the Number of enrolments of both sexes in Iceland in 1974 to that in 1978?
Ensure brevity in your answer.  1.08. What is the ratio of the Number of enrolments of both sexes in Morocco in 1974 to that in 1978?
Make the answer very short. 0.75. What is the ratio of the Number of enrolments of both sexes in Europe(all income levels) in 1974 to that in 1979?
Ensure brevity in your answer.  1.05. What is the ratio of the Number of enrolments of both sexes of Sub-Saharan Africa (developing only) in 1974 to that in 1979?
Give a very brief answer. 0.71. What is the ratio of the Number of enrolments of both sexes of Iceland in 1974 to that in 1979?
Provide a short and direct response. 1.1. What is the ratio of the Number of enrolments of both sexes in Morocco in 1974 to that in 1979?
Offer a very short reply. 0.69. What is the ratio of the Number of enrolments of both sexes in Europe(all income levels) in 1974 to that in 1980?
Make the answer very short. 1.05. What is the ratio of the Number of enrolments of both sexes of Sub-Saharan Africa (developing only) in 1974 to that in 1980?
Offer a terse response. 0.66. What is the ratio of the Number of enrolments of both sexes in Iceland in 1974 to that in 1980?
Your response must be concise. 1.1. What is the ratio of the Number of enrolments of both sexes of Morocco in 1974 to that in 1980?
Your response must be concise. 0.65. What is the ratio of the Number of enrolments of both sexes of Sub-Saharan Africa (developing only) in 1975 to that in 1976?
Ensure brevity in your answer.  0.96. What is the ratio of the Number of enrolments of both sexes in Iceland in 1975 to that in 1976?
Make the answer very short. 1.02. What is the ratio of the Number of enrolments of both sexes in Morocco in 1975 to that in 1976?
Offer a very short reply. 0.91. What is the ratio of the Number of enrolments of both sexes of Europe(all income levels) in 1975 to that in 1977?
Offer a very short reply. 1.02. What is the ratio of the Number of enrolments of both sexes of Sub-Saharan Africa (developing only) in 1975 to that in 1977?
Ensure brevity in your answer.  0.89. What is the ratio of the Number of enrolments of both sexes in Morocco in 1975 to that in 1977?
Give a very brief answer. 0.85. What is the ratio of the Number of enrolments of both sexes in Europe(all income levels) in 1975 to that in 1978?
Offer a very short reply. 1.03. What is the ratio of the Number of enrolments of both sexes in Sub-Saharan Africa (developing only) in 1975 to that in 1978?
Your response must be concise. 0.82. What is the ratio of the Number of enrolments of both sexes of Iceland in 1975 to that in 1978?
Provide a succinct answer. 1.07. What is the ratio of the Number of enrolments of both sexes in Morocco in 1975 to that in 1978?
Your answer should be compact. 0.79. What is the ratio of the Number of enrolments of both sexes in Europe(all income levels) in 1975 to that in 1979?
Your response must be concise. 1.03. What is the ratio of the Number of enrolments of both sexes in Sub-Saharan Africa (developing only) in 1975 to that in 1979?
Keep it short and to the point. 0.75. What is the ratio of the Number of enrolments of both sexes of Iceland in 1975 to that in 1979?
Offer a terse response. 1.09. What is the ratio of the Number of enrolments of both sexes of Morocco in 1975 to that in 1979?
Your answer should be very brief. 0.73. What is the ratio of the Number of enrolments of both sexes of Europe(all income levels) in 1975 to that in 1980?
Your answer should be very brief. 1.04. What is the ratio of the Number of enrolments of both sexes of Sub-Saharan Africa (developing only) in 1975 to that in 1980?
Provide a short and direct response. 0.7. What is the ratio of the Number of enrolments of both sexes in Iceland in 1975 to that in 1980?
Provide a short and direct response. 1.09. What is the ratio of the Number of enrolments of both sexes in Morocco in 1975 to that in 1980?
Your response must be concise. 0.69. What is the ratio of the Number of enrolments of both sexes in Sub-Saharan Africa (developing only) in 1976 to that in 1977?
Your answer should be compact. 0.93. What is the ratio of the Number of enrolments of both sexes in Iceland in 1976 to that in 1977?
Offer a terse response. 1.02. What is the ratio of the Number of enrolments of both sexes of Morocco in 1976 to that in 1977?
Offer a very short reply. 0.93. What is the ratio of the Number of enrolments of both sexes of Europe(all income levels) in 1976 to that in 1978?
Offer a terse response. 1.02. What is the ratio of the Number of enrolments of both sexes of Sub-Saharan Africa (developing only) in 1976 to that in 1978?
Ensure brevity in your answer.  0.85. What is the ratio of the Number of enrolments of both sexes of Iceland in 1976 to that in 1978?
Your answer should be very brief. 1.05. What is the ratio of the Number of enrolments of both sexes of Morocco in 1976 to that in 1978?
Keep it short and to the point. 0.86. What is the ratio of the Number of enrolments of both sexes of Europe(all income levels) in 1976 to that in 1979?
Your response must be concise. 1.03. What is the ratio of the Number of enrolments of both sexes in Sub-Saharan Africa (developing only) in 1976 to that in 1979?
Your answer should be compact. 0.78. What is the ratio of the Number of enrolments of both sexes in Iceland in 1976 to that in 1979?
Ensure brevity in your answer.  1.07. What is the ratio of the Number of enrolments of both sexes of Morocco in 1976 to that in 1979?
Your response must be concise. 0.8. What is the ratio of the Number of enrolments of both sexes of Europe(all income levels) in 1976 to that in 1980?
Make the answer very short. 1.04. What is the ratio of the Number of enrolments of both sexes of Sub-Saharan Africa (developing only) in 1976 to that in 1980?
Give a very brief answer. 0.73. What is the ratio of the Number of enrolments of both sexes of Iceland in 1976 to that in 1980?
Give a very brief answer. 1.07. What is the ratio of the Number of enrolments of both sexes in Morocco in 1976 to that in 1980?
Your answer should be very brief. 0.75. What is the ratio of the Number of enrolments of both sexes of Europe(all income levels) in 1977 to that in 1978?
Make the answer very short. 1.01. What is the ratio of the Number of enrolments of both sexes of Sub-Saharan Africa (developing only) in 1977 to that in 1978?
Provide a succinct answer. 0.92. What is the ratio of the Number of enrolments of both sexes in Iceland in 1977 to that in 1978?
Give a very brief answer. 1.03. What is the ratio of the Number of enrolments of both sexes of Morocco in 1977 to that in 1978?
Offer a terse response. 0.93. What is the ratio of the Number of enrolments of both sexes of Europe(all income levels) in 1977 to that in 1979?
Give a very brief answer. 1.02. What is the ratio of the Number of enrolments of both sexes in Sub-Saharan Africa (developing only) in 1977 to that in 1979?
Your answer should be compact. 0.84. What is the ratio of the Number of enrolments of both sexes in Iceland in 1977 to that in 1979?
Provide a succinct answer. 1.05. What is the ratio of the Number of enrolments of both sexes of Morocco in 1977 to that in 1979?
Keep it short and to the point. 0.87. What is the ratio of the Number of enrolments of both sexes in Europe(all income levels) in 1977 to that in 1980?
Provide a succinct answer. 1.02. What is the ratio of the Number of enrolments of both sexes of Sub-Saharan Africa (developing only) in 1977 to that in 1980?
Provide a succinct answer. 0.79. What is the ratio of the Number of enrolments of both sexes of Iceland in 1977 to that in 1980?
Your answer should be compact. 1.05. What is the ratio of the Number of enrolments of both sexes of Morocco in 1977 to that in 1980?
Your answer should be very brief. 0.81. What is the ratio of the Number of enrolments of both sexes in Europe(all income levels) in 1978 to that in 1979?
Provide a short and direct response. 1.01. What is the ratio of the Number of enrolments of both sexes in Sub-Saharan Africa (developing only) in 1978 to that in 1979?
Offer a terse response. 0.91. What is the ratio of the Number of enrolments of both sexes in Iceland in 1978 to that in 1979?
Offer a very short reply. 1.02. What is the ratio of the Number of enrolments of both sexes of Morocco in 1978 to that in 1979?
Provide a short and direct response. 0.93. What is the ratio of the Number of enrolments of both sexes in Europe(all income levels) in 1978 to that in 1980?
Provide a short and direct response. 1.02. What is the ratio of the Number of enrolments of both sexes of Sub-Saharan Africa (developing only) in 1978 to that in 1980?
Make the answer very short. 0.85. What is the ratio of the Number of enrolments of both sexes in Iceland in 1978 to that in 1980?
Provide a succinct answer. 1.02. What is the ratio of the Number of enrolments of both sexes in Morocco in 1978 to that in 1980?
Ensure brevity in your answer.  0.87. What is the ratio of the Number of enrolments of both sexes of Europe(all income levels) in 1979 to that in 1980?
Provide a succinct answer. 1.01. What is the ratio of the Number of enrolments of both sexes of Sub-Saharan Africa (developing only) in 1979 to that in 1980?
Your answer should be compact. 0.93. What is the ratio of the Number of enrolments of both sexes of Morocco in 1979 to that in 1980?
Ensure brevity in your answer.  0.94. What is the difference between the highest and the second highest Number of enrolments of both sexes in Europe(all income levels)?
Keep it short and to the point. 5.63e+05. What is the difference between the highest and the second highest Number of enrolments of both sexes in Sub-Saharan Africa (developing only)?
Your answer should be compact. 3.28e+06. What is the difference between the highest and the second highest Number of enrolments of both sexes of Iceland?
Your answer should be very brief. 171. What is the difference between the highest and the second highest Number of enrolments of both sexes in Morocco?
Give a very brief answer. 1.27e+05. What is the difference between the highest and the lowest Number of enrolments of both sexes in Europe(all income levels)?
Provide a short and direct response. 3.71e+06. What is the difference between the highest and the lowest Number of enrolments of both sexes of Sub-Saharan Africa (developing only)?
Make the answer very short. 1.90e+07. What is the difference between the highest and the lowest Number of enrolments of both sexes of Iceland?
Offer a very short reply. 2618. What is the difference between the highest and the lowest Number of enrolments of both sexes in Morocco?
Give a very brief answer. 7.76e+05. 